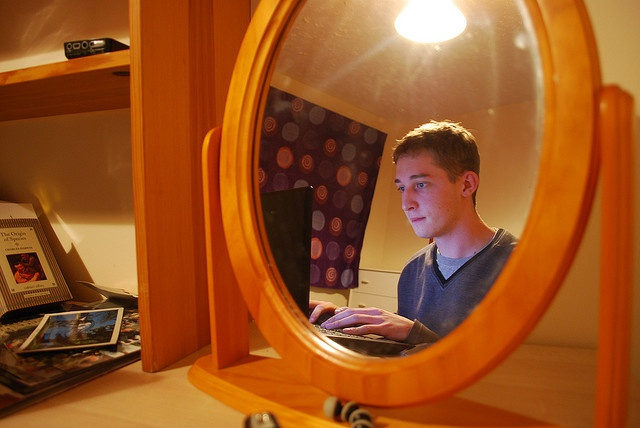Describe the objects in this image and their specific colors. I can see people in maroon, brown, and black tones, book in maroon, olive, and black tones, laptop in maroon, black, brown, and tan tones, and book in maroon, black, and gray tones in this image. 